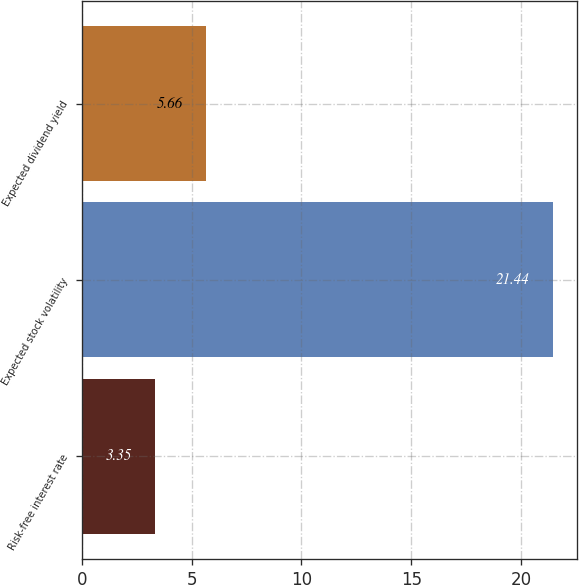Convert chart. <chart><loc_0><loc_0><loc_500><loc_500><bar_chart><fcel>Risk-free interest rate<fcel>Expected stock volatility<fcel>Expected dividend yield<nl><fcel>3.35<fcel>21.44<fcel>5.66<nl></chart> 